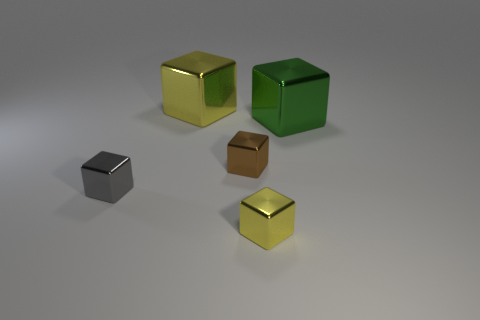Subtract all gray metal blocks. How many blocks are left? 4 Subtract all green cubes. How many cubes are left? 4 Subtract all red cubes. Subtract all green cylinders. How many cubes are left? 5 Add 4 large gray balls. How many objects exist? 9 Add 4 large metal blocks. How many large metal blocks are left? 6 Add 1 big yellow metal things. How many big yellow metal things exist? 2 Subtract 0 red blocks. How many objects are left? 5 Subtract all brown cubes. Subtract all tiny gray metallic objects. How many objects are left? 3 